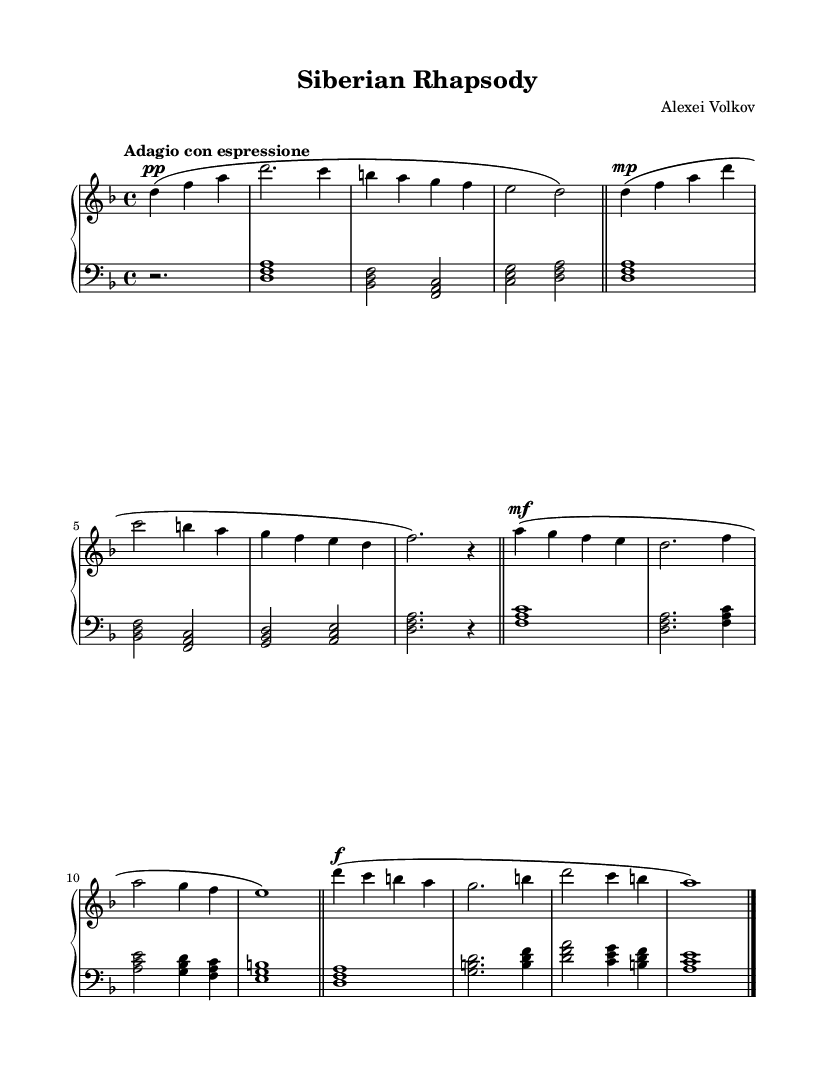What is the key signature of this music? The key signature is D minor, which has one flat (B flat). The presence of the B flat in the notes and absence of any sharps confirms this.
Answer: D minor What is the time signature of this music? The time signature is 4/4, which means there are four beats in a measure and each quarter note gets one beat. This is indicated at the beginning of the score.
Answer: 4/4 What is the tempo marking of this music? The tempo marking is "Adagio con espressione", which suggests a slow and expressive tempo. This marking is found at the beginning of the sheet music.
Answer: Adagio con espressione How many measures are in the music? There are eight measures in total. Each measure is separated by a bar line, and counting these provides the total number.
Answer: 8 What dynamic marking is indicated for the first phrase? The dynamic marking for the first phrase is pianissimo (pp), which means very soft. This is indicated right before the first note of the phrase.
Answer: pianissimo Which section contains the first forte marking? The first forte (f) marking appears in the third measure. This is observed in the dynamic markings above the staff during that measure.
Answer: Third measure What kind of emotional expression is suggested by the tempo and dynamics of this piece? The combination of "Adagio con espressione" and the range of dynamic markings suggests a deeply emotional and reflective expression, common in Romantic piano concertos.
Answer: Emotional reflection 